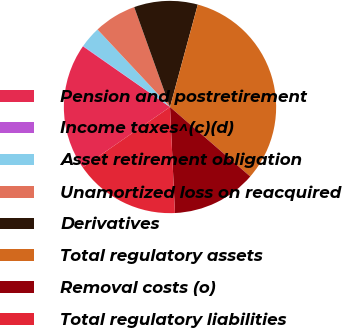Convert chart to OTSL. <chart><loc_0><loc_0><loc_500><loc_500><pie_chart><fcel>Pension and postretirement<fcel>Income taxes^(c)(d)<fcel>Asset retirement obligation<fcel>Unamortized loss on reacquired<fcel>Derivatives<fcel>Total regulatory assets<fcel>Removal costs (o)<fcel>Total regulatory liabilities<nl><fcel>19.31%<fcel>0.07%<fcel>3.28%<fcel>6.49%<fcel>9.69%<fcel>32.14%<fcel>12.9%<fcel>16.11%<nl></chart> 